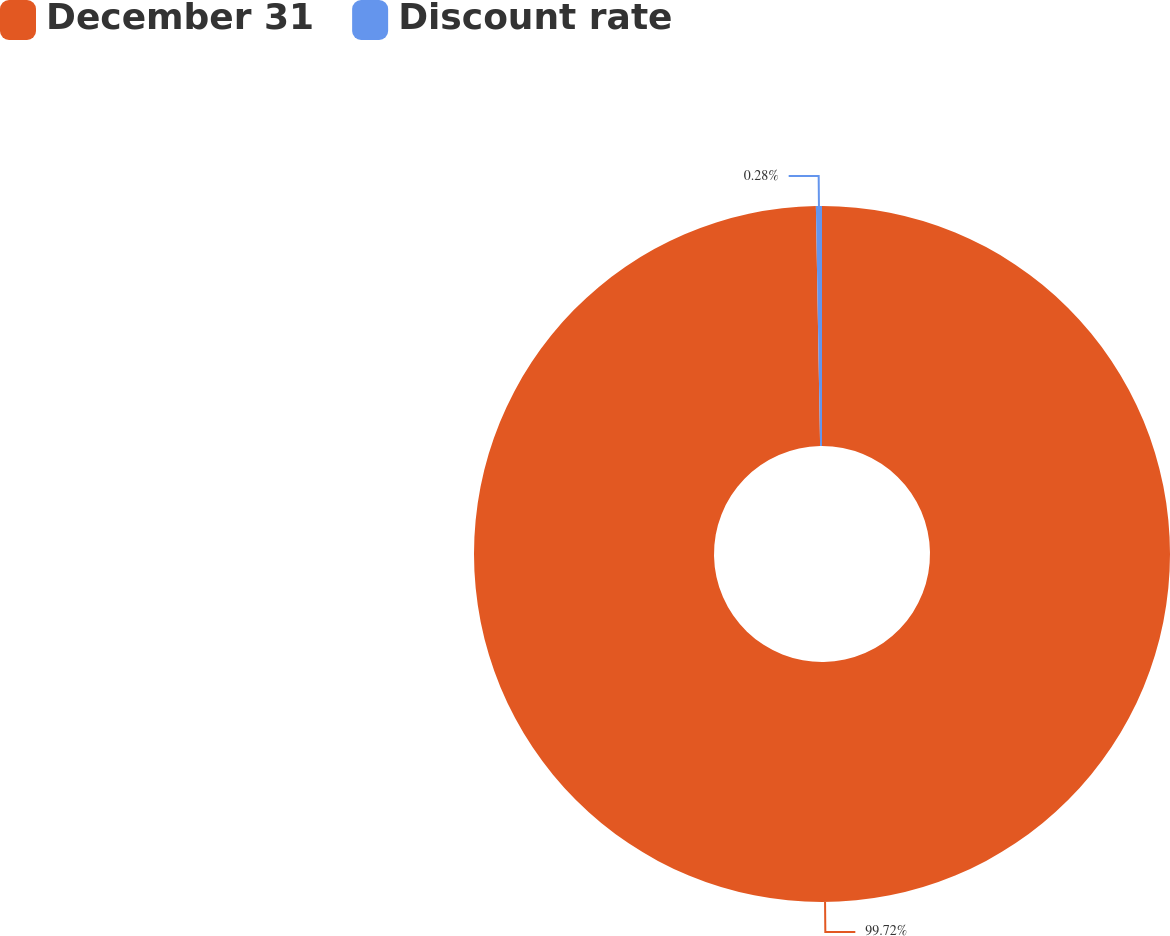Convert chart. <chart><loc_0><loc_0><loc_500><loc_500><pie_chart><fcel>December 31<fcel>Discount rate<nl><fcel>99.72%<fcel>0.28%<nl></chart> 